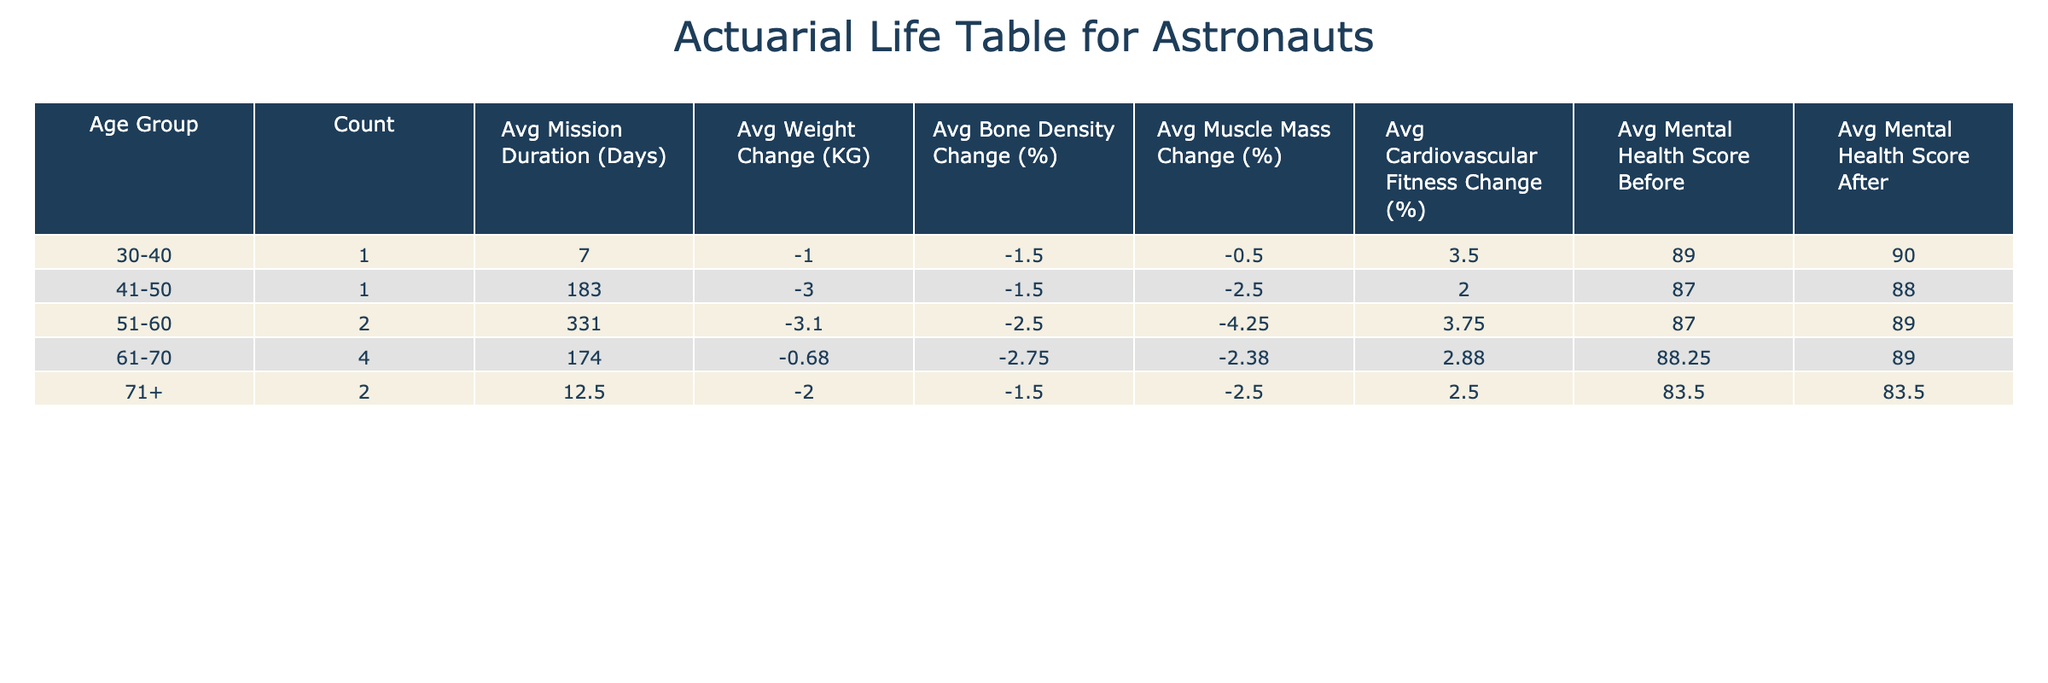What is the average mission duration for astronauts aged 61-70? To find the average mission duration for astronauts in the 61-70 age group, we look at the table and identify those astronauts: Peggy Whitson (665 days), John Young (14 days), Sally Ride (6 days), and Lori Garver (10 days). We sum their mission durations: 665 + 14 + 6 + 10 = 695 days. There are 4 astronauts, so the average mission duration is 695 / 4 = 173.75 days.
Answer: 173.75 days How many astronauts had an excellent health status before their missions? We can look at the column for health status before the mission and count the entries marked as excellent. Checking the data, we see Peggy Whitson, Franklin Chang-Diaz, and Sunita Williams all had excellent health status before the mission, which gives us a total of 3 astronauts.
Answer: 3 What was the average weight change for astronauts classified as "Good" health status after the mission? We focus on astronauts with "Good" health status and look at their weight changes after the mission: Buzz Aldrin (-1.5), John Young (-2.5), Chris Cassidy (-3.0), Sally Ride (-0.5), Lori Garver (-1.2), Mark Kelly (-4.0), Anna Fisher (-1.0). Summing these values gives -1.5 + -2.5 + -3.0 + -0.5 + -1.2 + -4.0 + -1.0 = -13.7. There are 7 data points, so the average weight change is -13.7 / 7 = -1.96 kg.
Answer: -1.96 kg Did any astronauts experience an increase in their mental health score after the mission? To answer this, we check the mental health scores before and after for each astronaut. We observe that Buzz Aldrin increased from 85 to 87, Peggy Whitson from 90 to 92, Anna Fisher from 89 to 90, Sunita Williams from 91 to 93, but John Young decreased from 82 to 80, and Lori Garver from 85 to 84. Therefore, there were 4 astronauts who experienced an increase.
Answer: Yes What was the difference in average muscle mass change between astronauts in the 51-60 age group and those in the 61-70 age group? First, we identify astronauts in the 51-60 age group: Chris Cassidy (-2.5), Franklin Chang-Diaz (-1.0), Mark Kelly (-3.5), and Sunita Williams (-5.0). Their average muscle mass change is (-2.5 + -1.0 + -3.5 + -5.0) / 4 = -3.00%. Now for the 61-70 age group: Peggy Whitson (-4.5), John Young (-3.0), Sally Ride (-1.0), Lori Garver (-3.0). Their average is (-4.5 + -3.0 + -1.0 + -3.0) / 4 = -2.875%. The difference between -3.00% and -2.875% is -3.00% - (-2.875%) = -0.125%.
Answer: -0.125% 